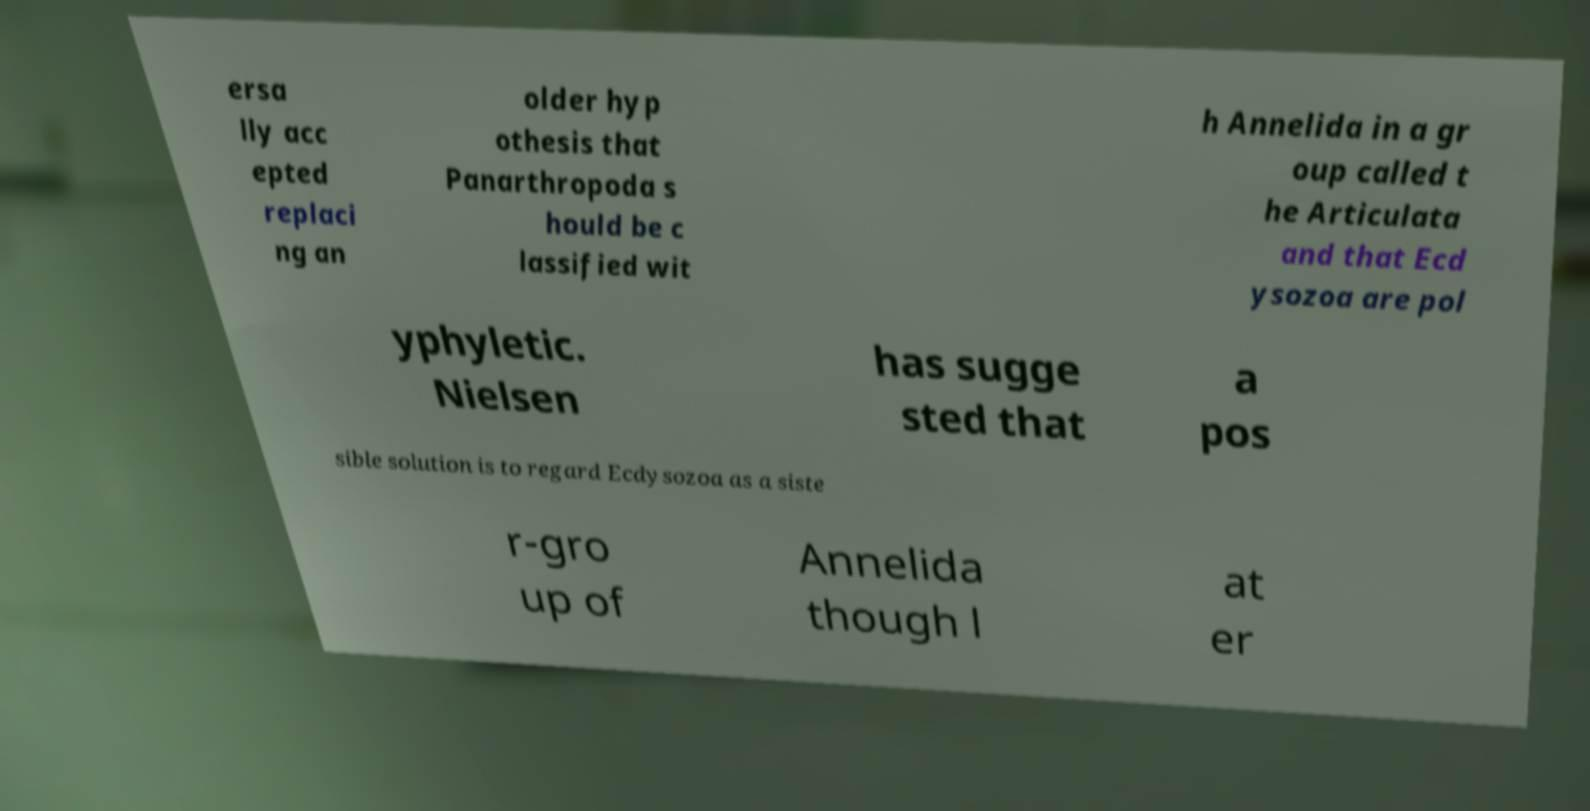Could you extract and type out the text from this image? ersa lly acc epted replaci ng an older hyp othesis that Panarthropoda s hould be c lassified wit h Annelida in a gr oup called t he Articulata and that Ecd ysozoa are pol yphyletic. Nielsen has sugge sted that a pos sible solution is to regard Ecdysozoa as a siste r-gro up of Annelida though l at er 